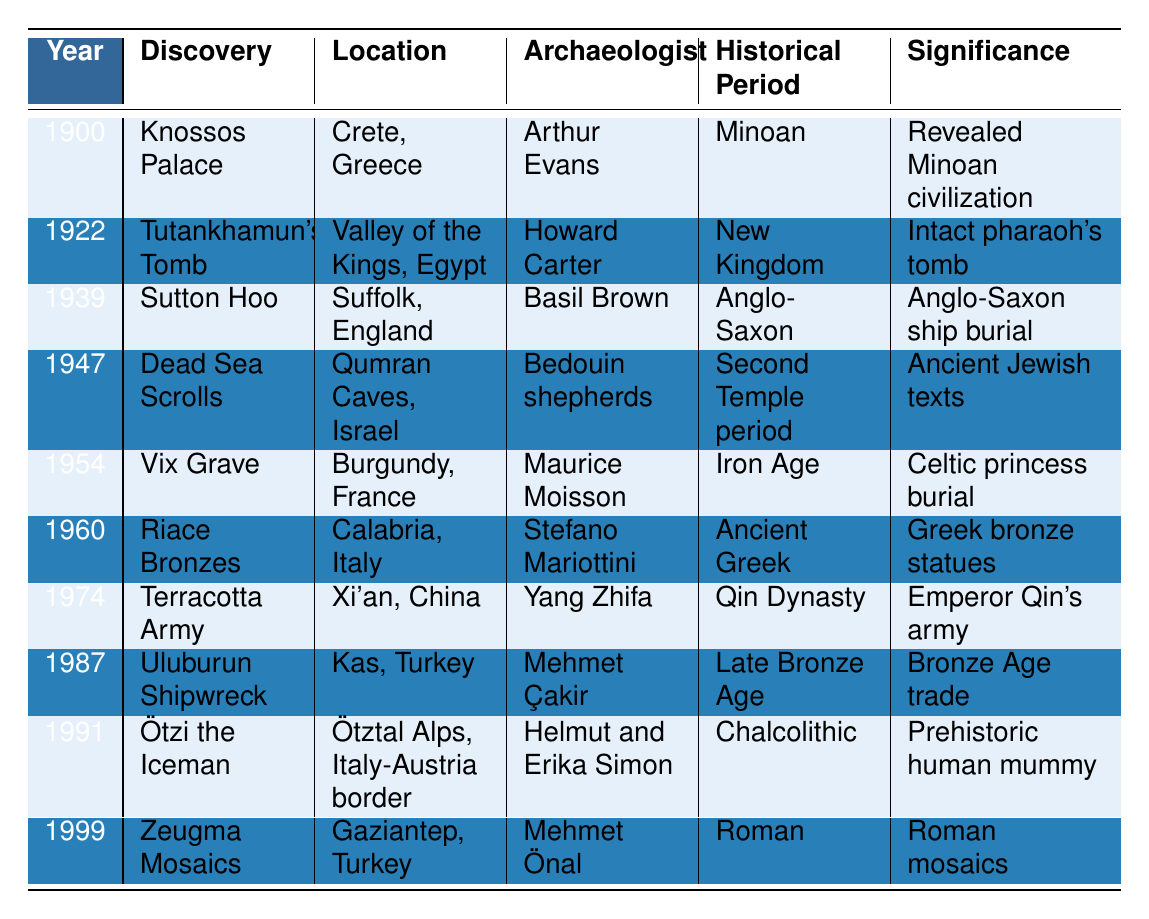What discovery occurred in 1922? The year 1922 in the table corresponds to the discovery of Tutankhamun's Tomb.
Answer: Tutankhamun's Tomb Who was the archaeologist that found the Terracotta Army? In the table, Yang Zhifa is listed as the archaeologist who discovered the Terracotta Army in 1974.
Answer: Yang Zhifa Which discoveries are associated with ancient human remains? The table shows two discoveries related to ancient human remains: Ötzi the Iceman (1991) and the Dead Sea Scrolls (1947).
Answer: Ötzi the Iceman and Dead Sea Scrolls Which discovery has the significance of revealing Minoan civilization? The table indicates that the Knossos Palace, discovered in 1900, is significant for revealing Minoan civilization.
Answer: Knossos Palace Did any discoveries take place in the 1960s? Yes, the Riace Bronzes were discovered in 1960 according to the table.
Answer: Yes What location is associated with the discovery of the Vix Grave? The Vix Grave is associated with Burgundy, France, as stated in the table.
Answer: Burgundy, France Which historical period does the discovery of the Uluburun Shipwreck belong to? The table indicates that the Uluburun Shipwreck belongs to the Late Bronze Age period.
Answer: Late Bronze Age How many discoveries were made before 1950? The table shows that there were six discoveries made before 1950 (1900, 1922, 1939, 1947, 1954, 1960).
Answer: 6 What is the significance of the Minoan discovery made in 1900? According to the table, the Knossos Palace discovery in 1900 is significant because it revealed Minoan civilization.
Answer: Revealed Minoan civilization Which discovery occurred last in the 20th century, and who made it? The last discovery listed in the table is the Zeugma Mosaics in 1999, and it was made by Mehmet Önal.
Answer: Zeugma Mosaics by Mehmet Önal How many discoveries were made in Italy according to the table? The table indicates there are two discoveries from Italy: Riace Bronzes (1960) and Ötzi the Iceman (1991).
Answer: 2 Which discovery is linked to ancient Jewish texts? The Dead Sea Scrolls, discovered in 1947, are linked to ancient Jewish texts as per the table.
Answer: Dead Sea Scrolls What is the common factor among Sutton Hoo, Vix Grave, and Riace Bronzes regarding historical significance? All three discoveries—Sutton Hoo, Vix Grave, and Riace Bronzes—are significant for representing ancient burial practices and artifacts from different periods.
Answer: They represent ancient burial practices 